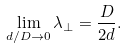<formula> <loc_0><loc_0><loc_500><loc_500>\lim _ { d / D \to 0 } \lambda _ { \perp } = \frac { D } { 2 d } .</formula> 